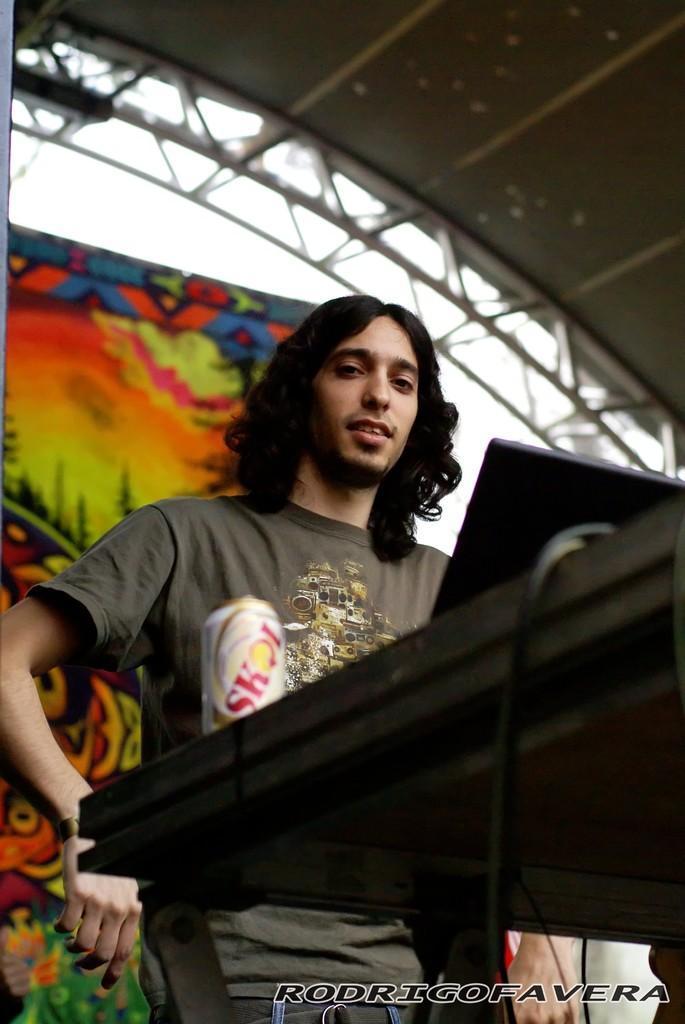Describe this image in one or two sentences. In this image we can see a person wearing T-shirt is standing here. Here we can see a table on which we can see tin and some objects are kept. The background of the image is slightly blurred, where we can see a banner, the roof and the sky. Here we can see the watermark on the bottom right side of the image. 